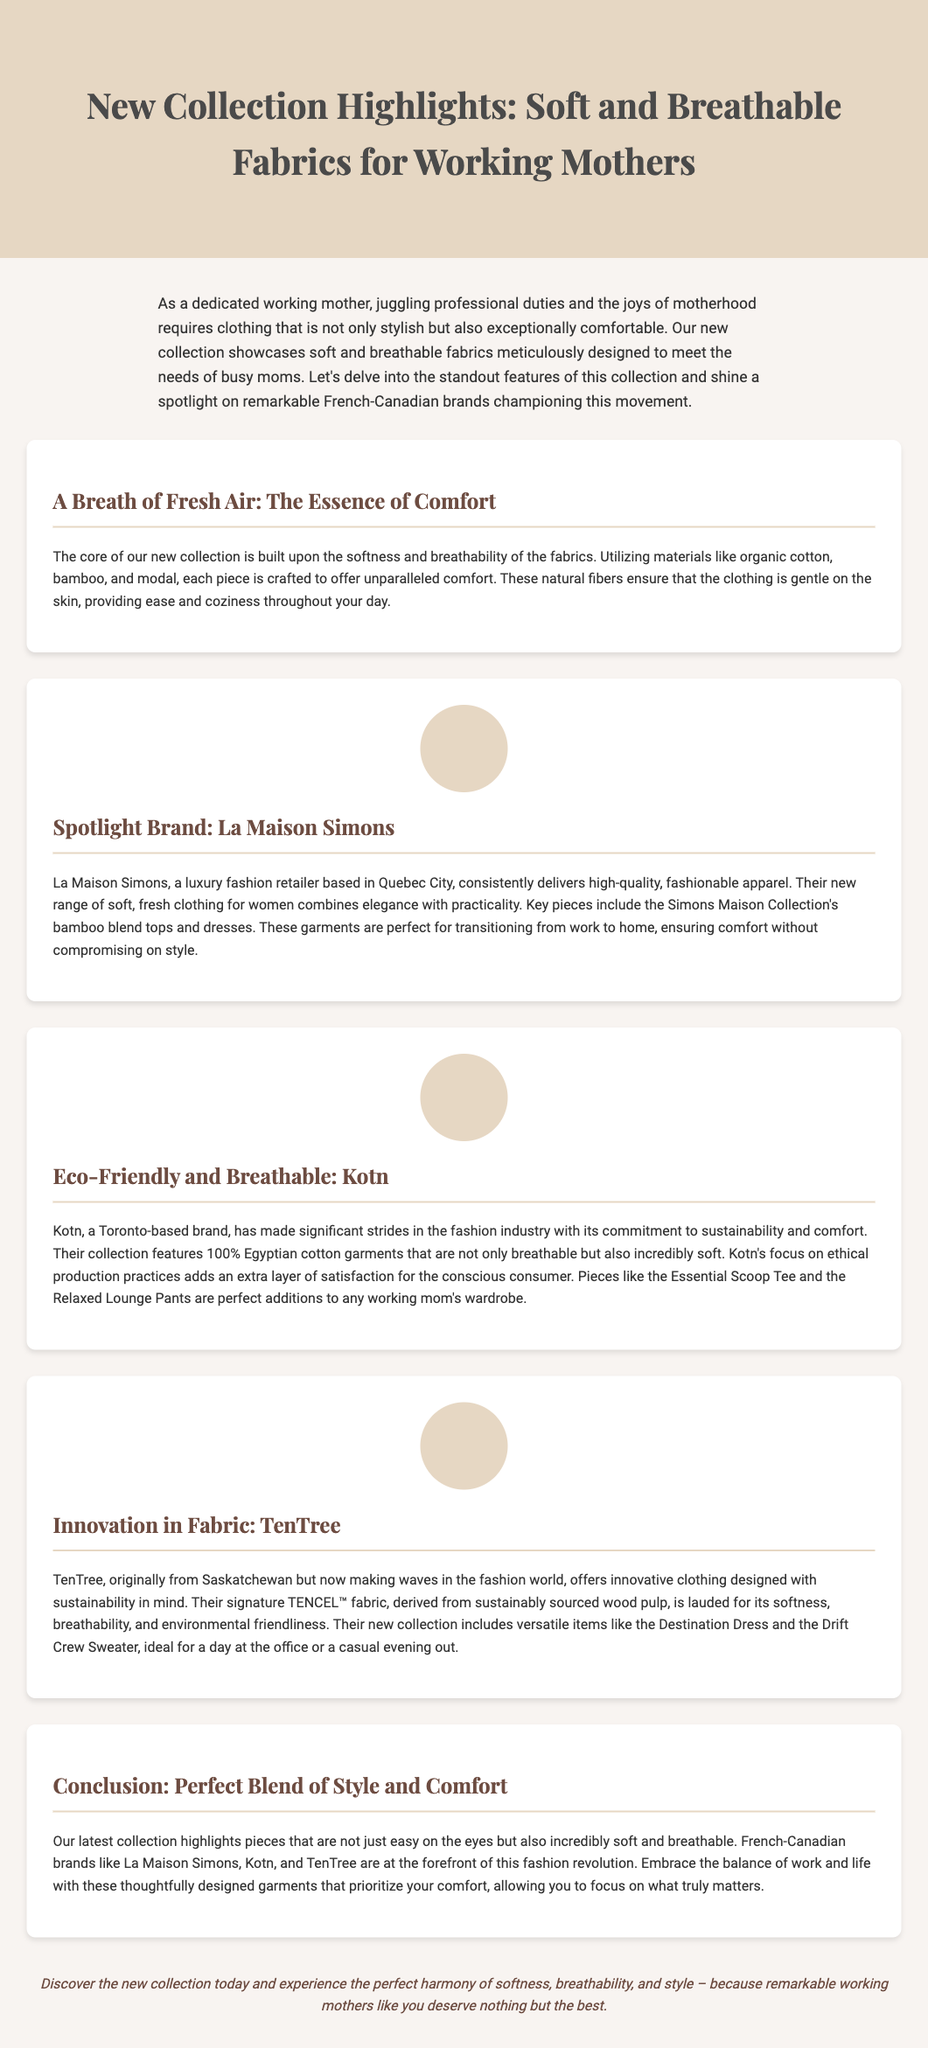What is the main theme of the collection? The document highlights soft and breathable fabrics designed for working mothers, focusing on comfort and style.
Answer: Soft and breathable fabrics Which fabric types are mentioned as core materials? The document lists organic cotton, bamboo, and modal as the primary materials used in the collection.
Answer: Organic cotton, bamboo, modal What is La Maison Simons known for? La Maison Simons is recognized for delivering high-quality, fashionable apparel that combines elegance with practicality.
Answer: High-quality, fashionable apparel Which Canadian brand focuses on sustainability with 100% Egyptian cotton? The document mentions that Kotn is committed to sustainability and offers 100% Egyptian cotton garments.
Answer: Kotn What fabric does TenTree use in their collection? The document states that TenTree uses TENCEL™ fabric, which is derived from sustainably sourced wood pulp.
Answer: TENCEL™ fabric What type of clothing is included in Kotn's collection? The document lists the Essential Scoop Tee and the Relaxed Lounge Pants as part of Kotn's offerings for working mothers.
Answer: Essential Scoop Tee, Relaxed Lounge Pants What is a featured product of La Maison Simons? The document highlights bamboo blend tops and dresses from the Simons Maison Collection as key pieces.
Answer: Bamboo blend tops and dresses How does the document describe the new collection? The document describes the collection as not just stylish but also incredibly comfortable for working mothers.
Answer: Stylish and incredibly comfortable What is the concluding message of the document? The conclusion encourages discovering the new collection to experience comfort, breathability, and style for working mothers.
Answer: Experience comfort, breathability, and style 